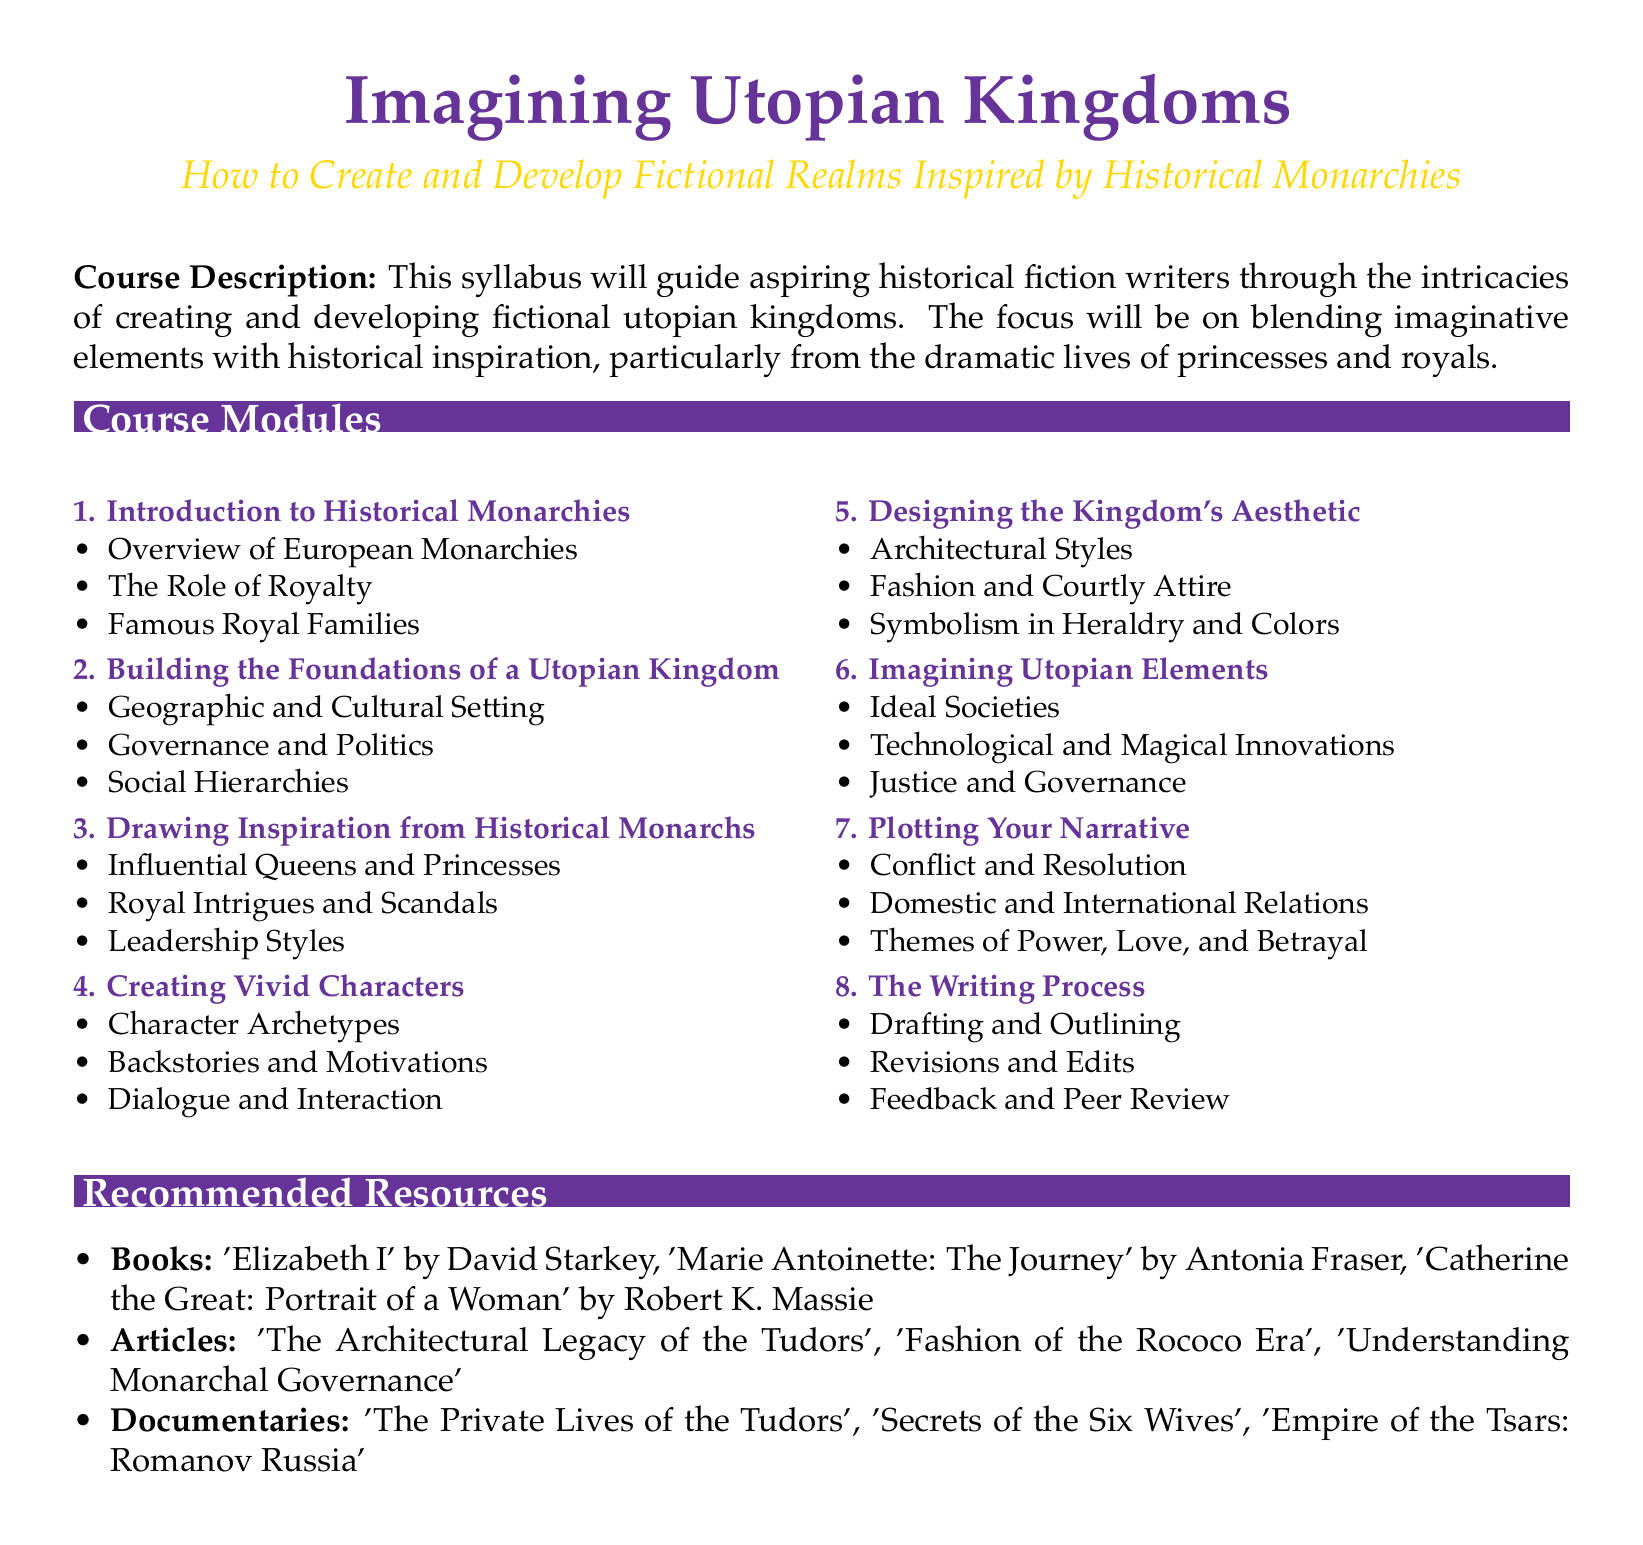What is the course title? The course title is prominently displayed at the beginning of the document and is "Imagining Utopian Kingdoms."
Answer: Imagining Utopian Kingdoms What module covers the role of royalty? The module that covers the role of royalty is titled "Introduction to Historical Monarchies."
Answer: Introduction to Historical Monarchies How many modules are there in the syllabus? The syllabus lists eight distinct modules under "Course Modules."
Answer: 8 What is the focus of module 6? Module 6 focuses on "Imagining Utopian Elements."
Answer: Imagining Utopian Elements Name one recommended book from the resources section. The resources section lists several books and one example is "Elizabeth I" by David Starkey.
Answer: Elizabeth I Which document type does this content represent? The content represents a syllabus, which provides an outline for a course.
Answer: Syllabus What is a key theme to explore in plotting your narrative? Domestic and international relations are highlighted as a key theme in the narrative plotting module.
Answer: Domestic and international relations Who is mentioned as an influential figure in module 3? The module on drawing inspiration from historical monarchs mentions "Influential Queens and Princesses."
Answer: Influential Queens and Princesses What is the emphasis of module 5 regarding the kingdom? Module 5 emphasizes "Designing the Kingdom's Aesthetic" which includes aspects like architecture and fashion.
Answer: Designing the Kingdom's Aesthetic 